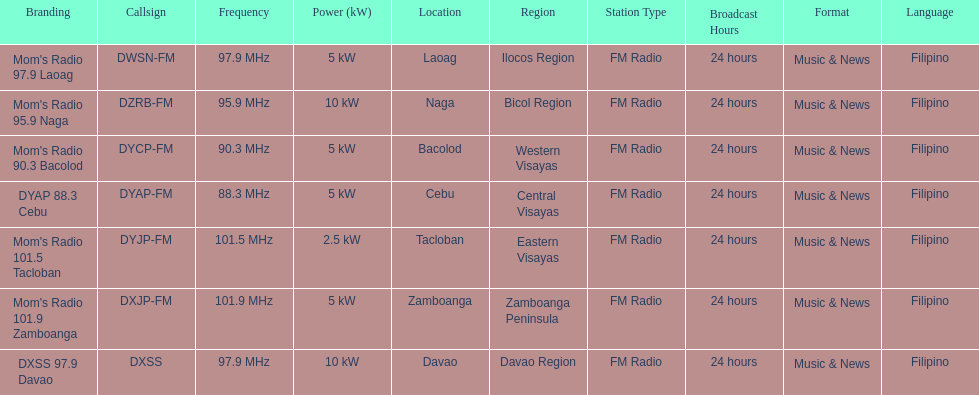What is the number of these stations broadcasting at a frequency of greater than 100 mhz? 2. 